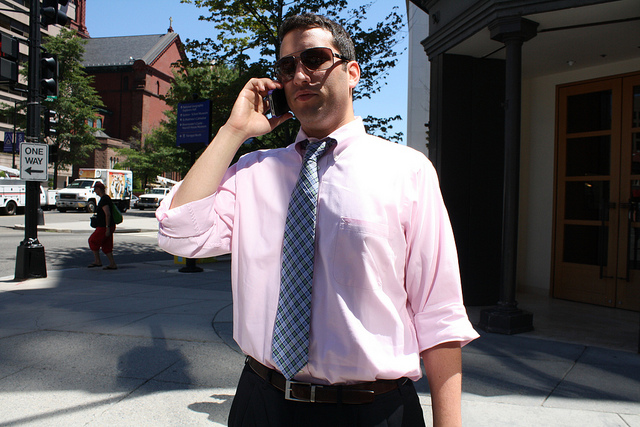Identify the text contained in this image. ONE WAY 